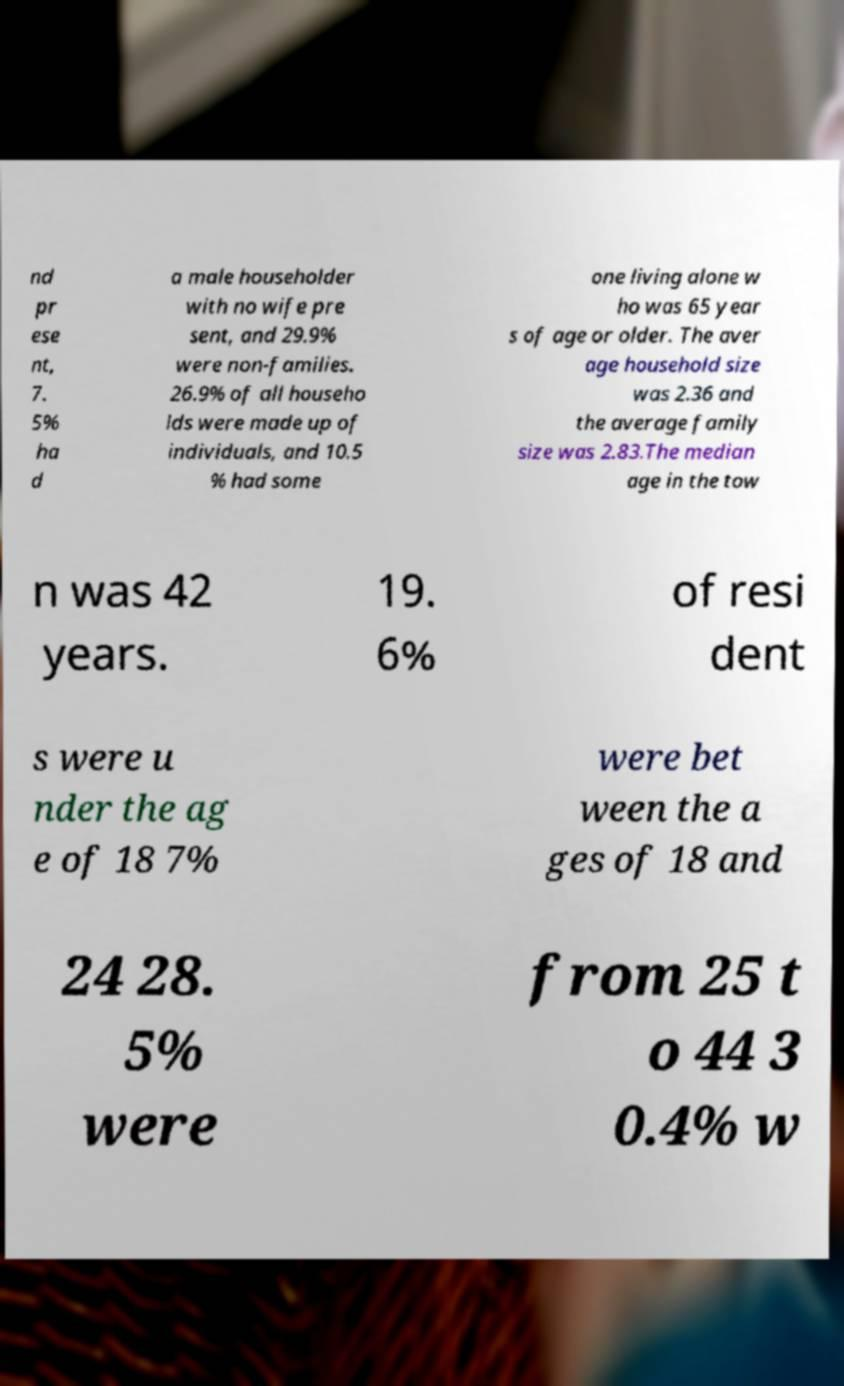Please read and relay the text visible in this image. What does it say? nd pr ese nt, 7. 5% ha d a male householder with no wife pre sent, and 29.9% were non-families. 26.9% of all househo lds were made up of individuals, and 10.5 % had some one living alone w ho was 65 year s of age or older. The aver age household size was 2.36 and the average family size was 2.83.The median age in the tow n was 42 years. 19. 6% of resi dent s were u nder the ag e of 18 7% were bet ween the a ges of 18 and 24 28. 5% were from 25 t o 44 3 0.4% w 